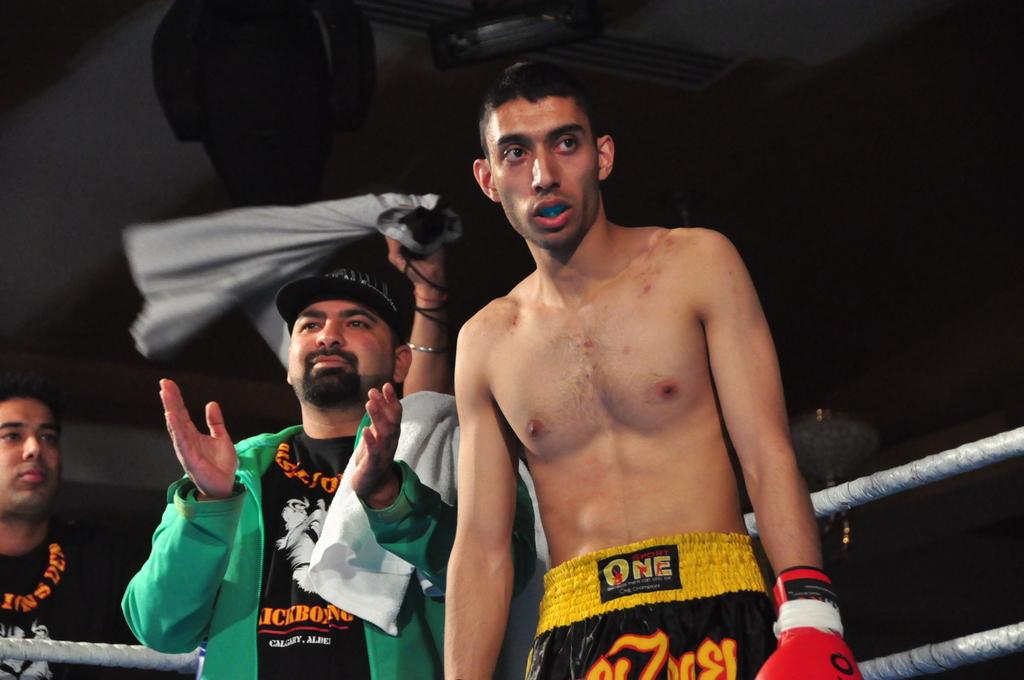<image>
Render a clear and concise summary of the photo. A boxer's shorts say "one" on the yellow waistband. 